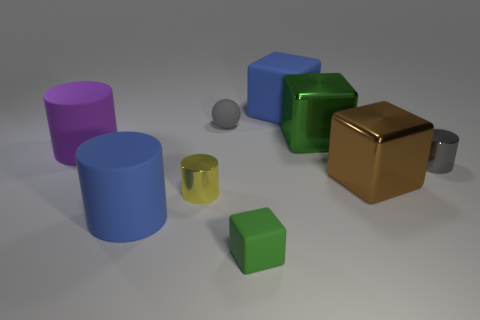What number of other things are the same shape as the large green object?
Your answer should be very brief. 3. The gray thing left of the green object that is in front of the blue matte thing that is left of the tiny yellow cylinder is made of what material?
Your response must be concise. Rubber. Is the number of small yellow cylinders behind the yellow metallic object the same as the number of gray things?
Your response must be concise. No. Do the large blue object behind the brown metallic object and the gray object to the right of the brown thing have the same material?
Keep it short and to the point. No. Are there any other things that are the same material as the large green cube?
Provide a short and direct response. Yes. Do the large metallic object behind the purple matte thing and the big blue object in front of the small yellow object have the same shape?
Your answer should be compact. No. Is the number of small gray rubber balls in front of the large green shiny block less than the number of small yellow cylinders?
Your response must be concise. Yes. How many big cylinders have the same color as the tiny matte sphere?
Your response must be concise. 0. There is a matte cube that is behind the tiny green matte thing; what is its size?
Offer a very short reply. Large. There is a large blue thing behind the tiny yellow object that is behind the blue object that is to the left of the yellow object; what shape is it?
Keep it short and to the point. Cube. 